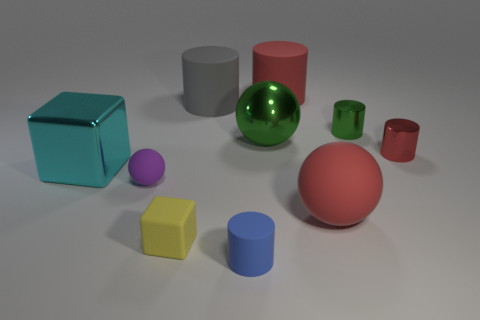Subtract all green cylinders. How many cylinders are left? 4 Subtract all gray matte cylinders. How many cylinders are left? 4 Subtract all purple cylinders. Subtract all purple cubes. How many cylinders are left? 5 Subtract all spheres. How many objects are left? 7 Subtract 1 blue cylinders. How many objects are left? 9 Subtract all large blue matte cylinders. Subtract all big green things. How many objects are left? 9 Add 1 large cylinders. How many large cylinders are left? 3 Add 1 green metallic spheres. How many green metallic spheres exist? 2 